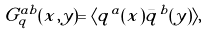Convert formula to latex. <formula><loc_0><loc_0><loc_500><loc_500>G _ { q } ^ { a b } ( x , y ) = \langle q ^ { a } ( x ) \bar { q } ^ { b } ( y ) \rangle ,</formula> 